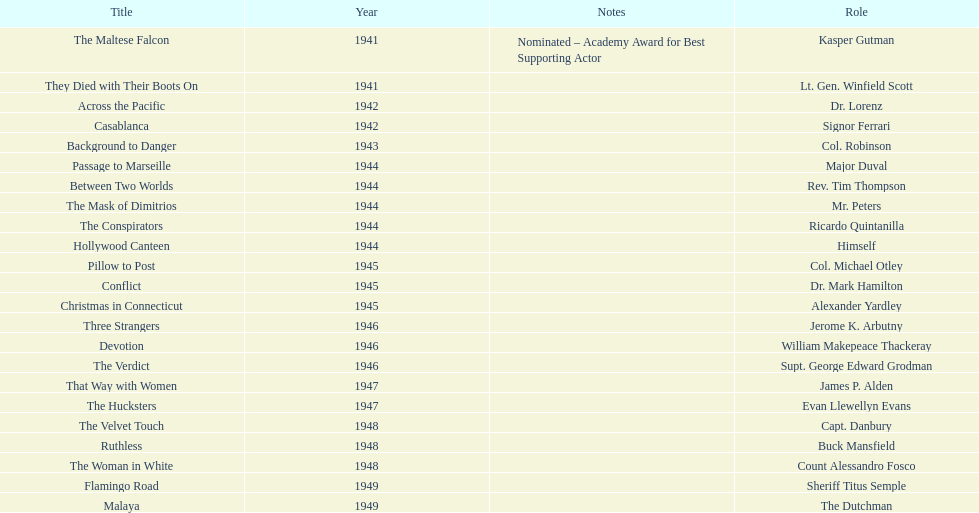How many movies has he been from 1941-1949. 23. 